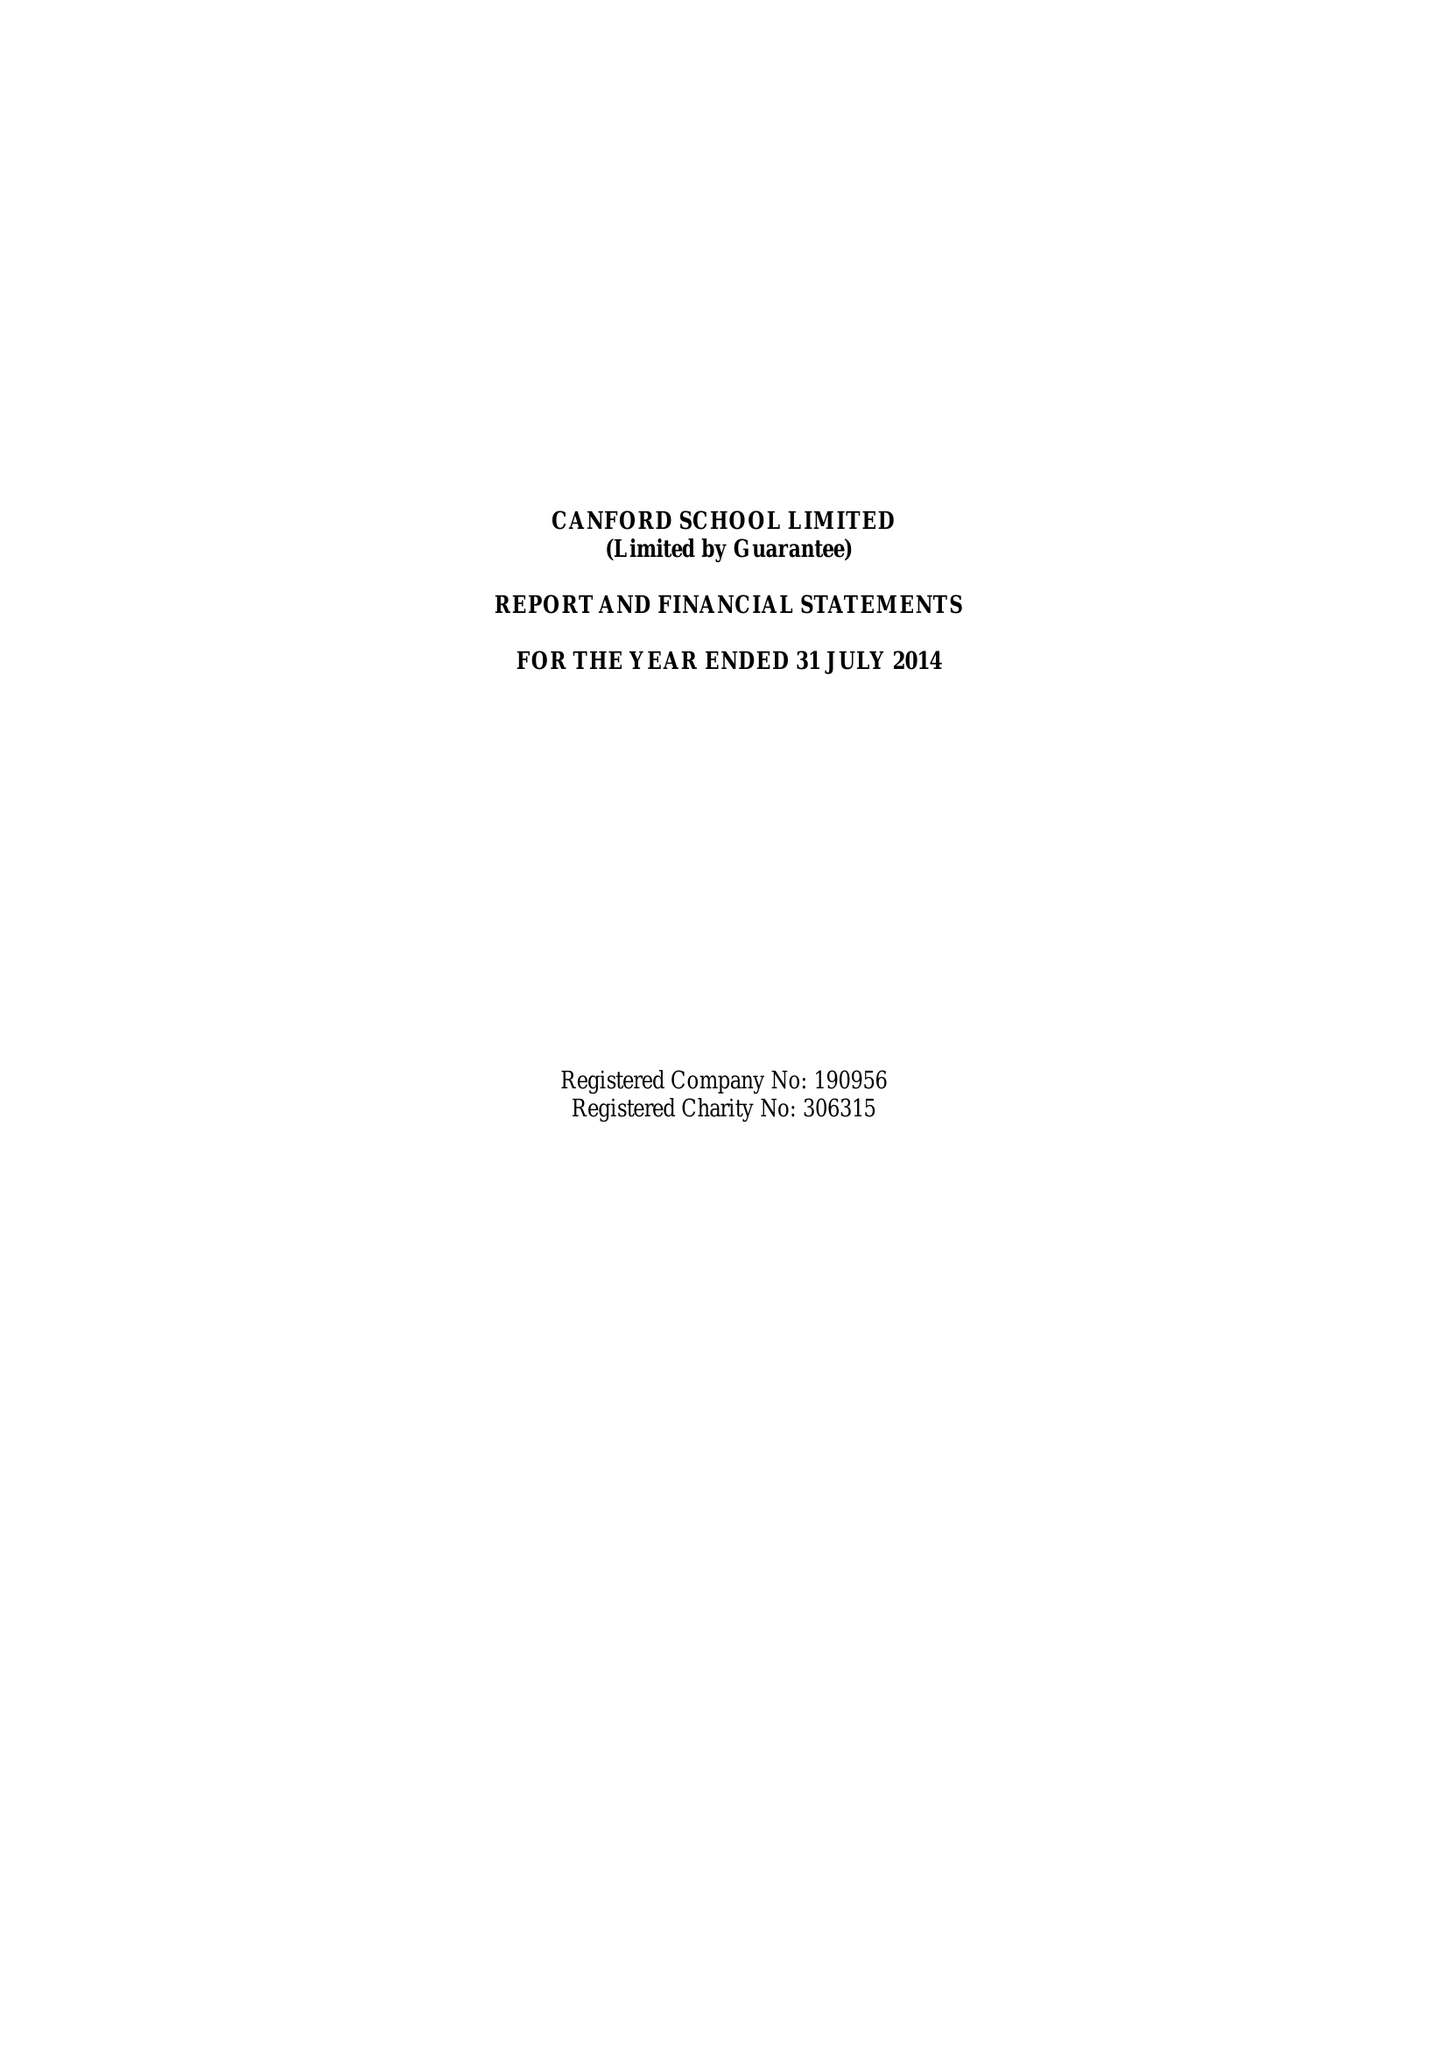What is the value for the address__post_town?
Answer the question using a single word or phrase. WIMBORNE 